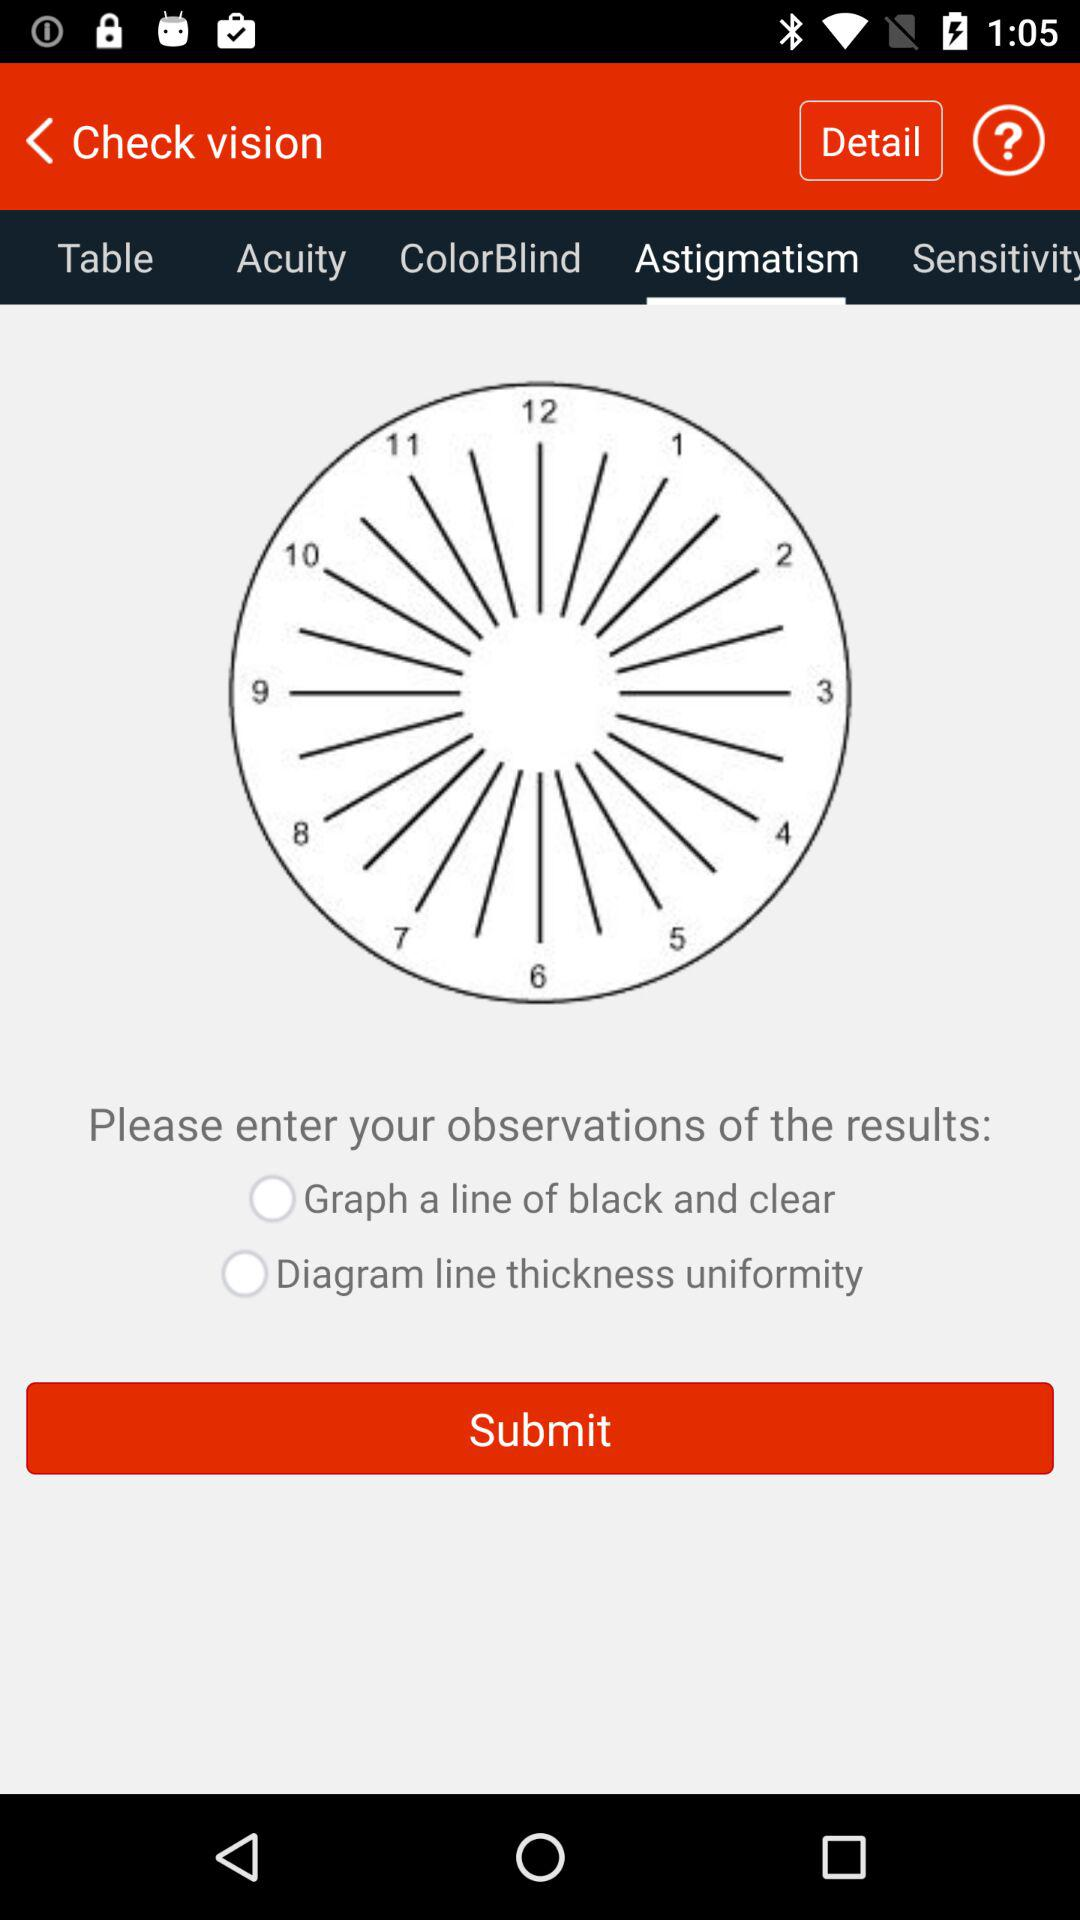What options are available? The options are "Table", "Acuity", "ColorBlind", "Astigmatism", and "Sensitivity". 